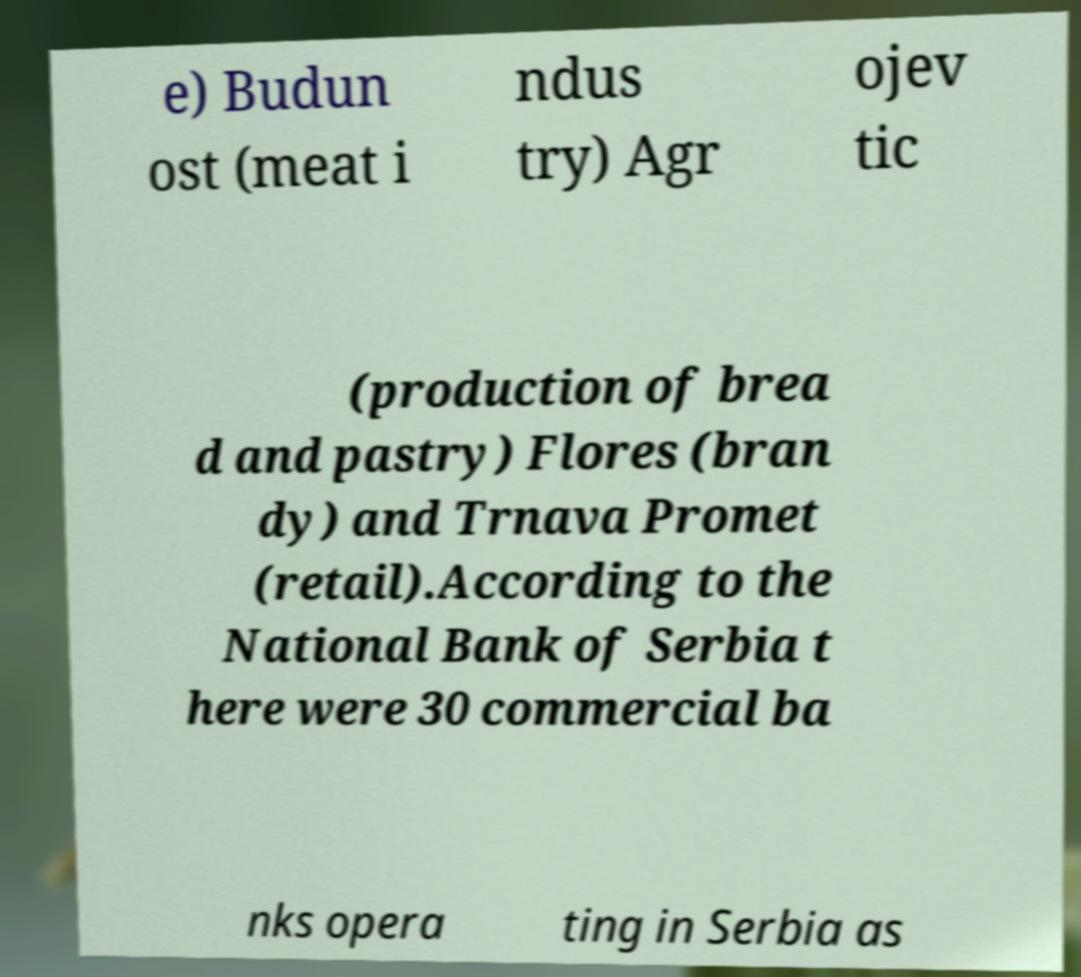What messages or text are displayed in this image? I need them in a readable, typed format. e) Budun ost (meat i ndus try) Agr ojev tic (production of brea d and pastry) Flores (bran dy) and Trnava Promet (retail).According to the National Bank of Serbia t here were 30 commercial ba nks opera ting in Serbia as 